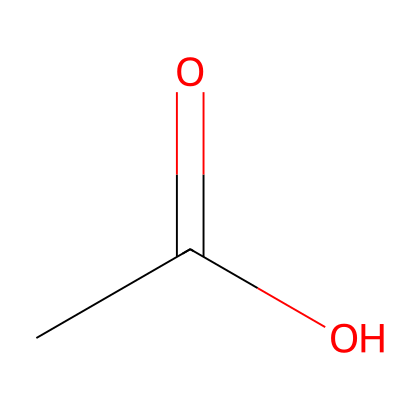What is the name of this chemical? This chemical is represented by the SMILES notation CC(=O)O, which corresponds to its common name acetic acid.
Answer: acetic acid How many carbon atoms are in acetic acid? Observing the SMILES CC(=O)O, we see 'CC', indicating there are 2 carbon atoms present in the structure.
Answer: 2 What is the functional group in acetic acid? The structure contains a carboxyl group (-COOH) indicated by the 'C(=O)O', which identifies it as a carboxylic acid, defining its functional properties.
Answer: carboxyl How many hydrogen atoms are in acetic acid? The carbon atoms in the structure are each bonded to hydrogen atoms. The first carbon has 3 hydrogens (from 'C' in CC) and the second carbon contributes 1 hydrogen, resulting in a total of 4 hydrogen atoms.
Answer: 4 Is acetic acid a strong or weak acid? Acetic acid is classified as a weak acid because it only partially dissociates in water, which can be inferred from its molecular composition and its common properties.
Answer: weak What is the molecular formula of acetic acid? From the SMILES representation CC(=O)O, we can ascertain the presence of 2 carbons, 4 hydrogens, and 2 oxygens, leading to the molecular formula C2H4O2.
Answer: C2H4O2 